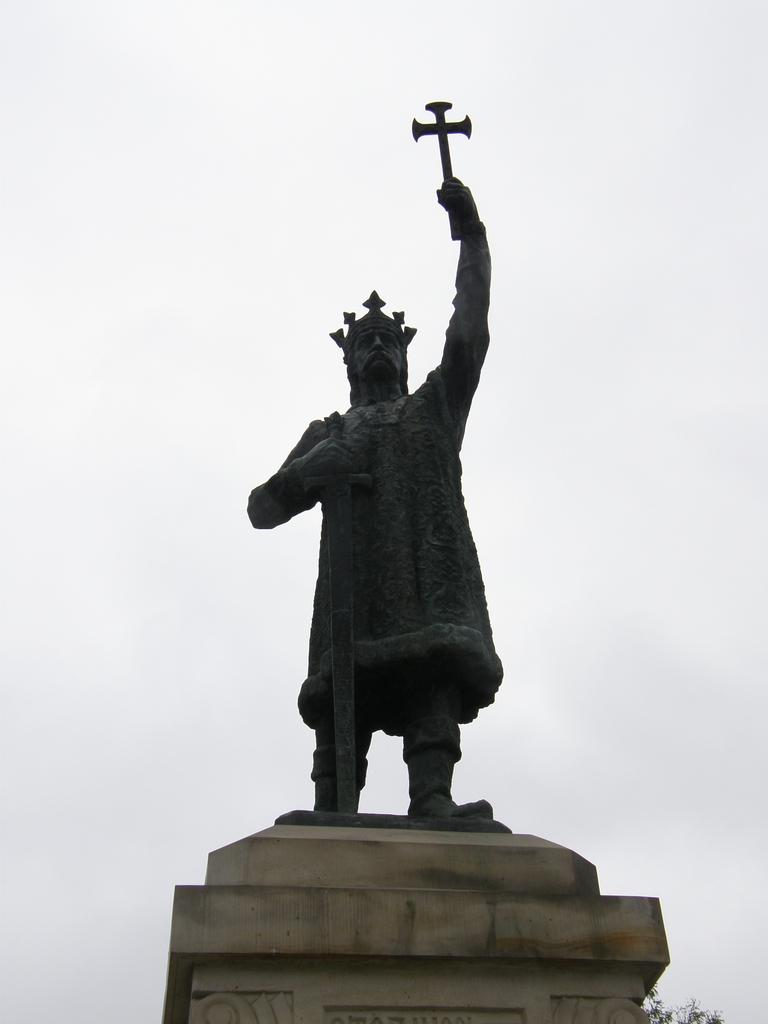What is the main subject of the image? There is a statue of a man in the image. What is the man in the statue wearing? The man is wearing a crown. What is the man holding in the statue? The man is holding a sword in his hand. Where is the statue located? The statue is on a pillar. What can be seen in the background of the image? The sky is visible in the background of the image. What type of sofa can be seen in the image? There is no sofa present in the image; it features a statue of a man on a pillar. What is the reason for the man holding the sword in the image? The image does not provide any information about the reason for the man holding the sword; it only shows the statue's appearance. 